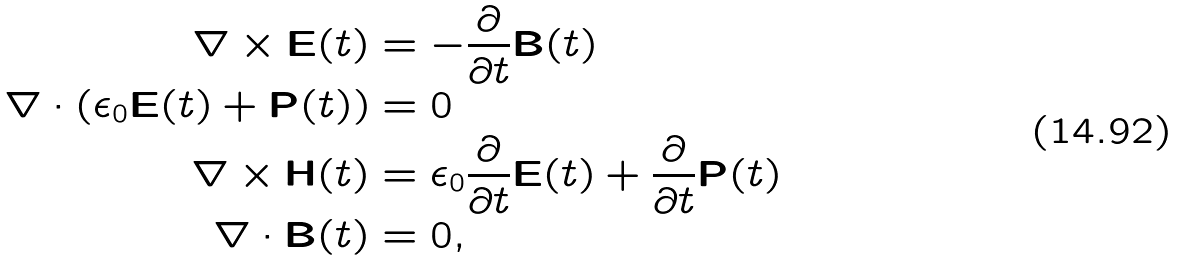<formula> <loc_0><loc_0><loc_500><loc_500>\nabla \times \mathbf E ( t ) & = - \frac { \partial } { \partial t } \mathbf B ( t ) \\ \nabla \cdot ( \epsilon _ { 0 } \mathbf E ( t ) + \mathbf P ( t ) ) & = 0 \\ \nabla \times \mathbf H ( t ) & = \epsilon _ { 0 } \frac { \partial } { \partial t } \mathbf E ( t ) + \frac { \partial } { \partial t } \mathbf P ( t ) \\ \nabla \cdot \mathbf B ( t ) & = 0 ,</formula> 